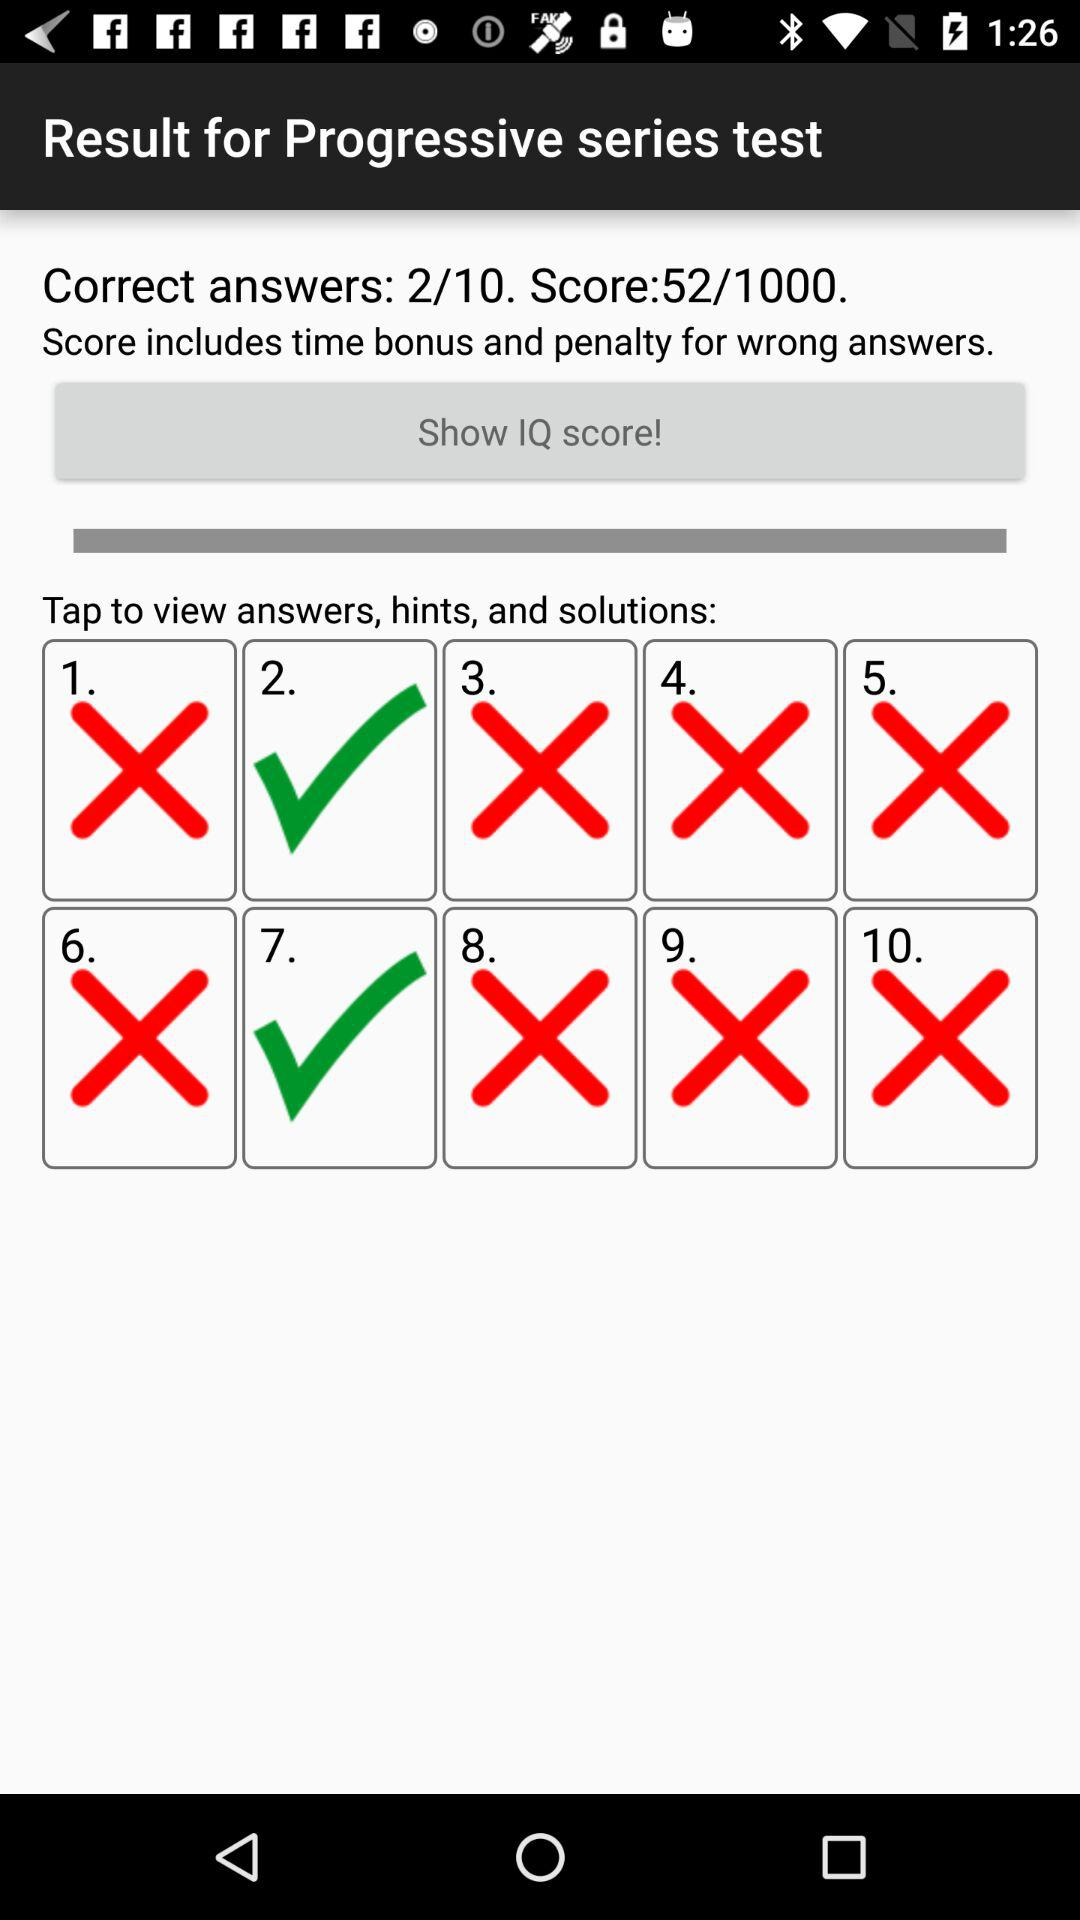How many correct answers does the user have?
Answer the question using a single word or phrase. 2 